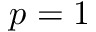<formula> <loc_0><loc_0><loc_500><loc_500>p = 1</formula> 